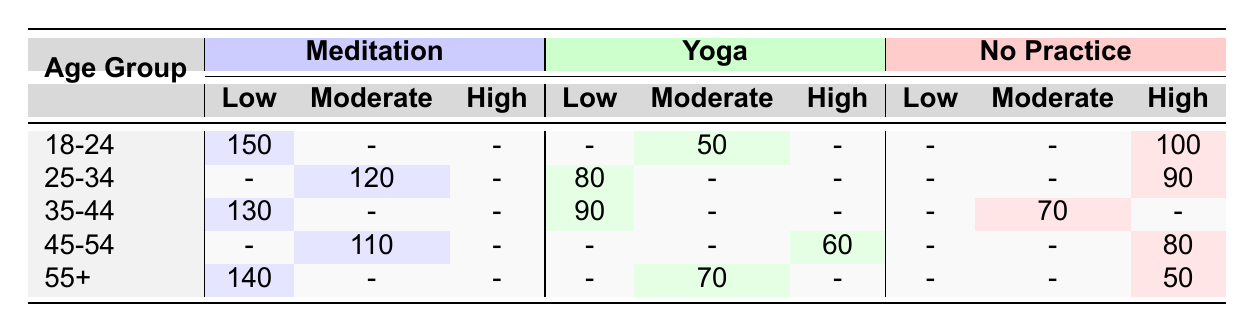What is the total number of people aged 18-24 practicing meditation? From the table, the count for people aged 18-24 practicing meditation is 150.
Answer: 150 Which mindfulness practice has the highest anxiety level among the 25-34 age group? For the age group 25-34, the mindfulness practice with the highest anxiety level is "No Practice," which has a count of 90.
Answer: No Practice What is the sum of all counts for the 35-44 age group? The counts for the 35-44 age group are: Meditation (130) + Yoga (90) + No Practice (70) = 290.
Answer: 290 Which age group has the most individuals reporting a low anxiety level from mindfulness practices? The age group 55+ practicing meditation shows the highest count for low anxiety level, with 140 individuals.
Answer: 55+ Do more individuals report a moderate anxiety level from meditation or yoga in the 45-54 age group? For the 45-54 age group, there are 110 individuals reporting moderate anxiety from meditation and 0 from yoga (as it is not reported). So, meditation has more individuals reporting moderate anxiety.
Answer: Meditation What is the difference in the number of individuals reporting high anxiety between the age groups 18-24 and 45-54? In the 18-24 age group, the number reporting high anxiety without any practice is 100, while in the 45-54 age group, it's 80. The difference is 100 - 80 = 20.
Answer: 20 Is it true that all age groups practicing meditation report at least some individuals with low anxiety levels? Yes, from the table, every age group reported individuals with low anxiety levels while practicing meditation.
Answer: Yes Among all practices, which one generally leads to the lowest anxiety levels across all age groups? Looking across the table, meditation consistently has the highest counts in the low anxiety column for each age group, indicating it leads to the lowest anxiety levels.
Answer: Meditation What percentage of individuals aged 55+ practicing yoga report moderate anxiety? The count of individuals aged 55+ practicing yoga with moderate anxiety is 70 out of 280 total individuals aged 55+ (70 + 140 + 50 = 260 is also an average). The percentage is approximately (70 / 280) * 100 = 25%.
Answer: 25% 